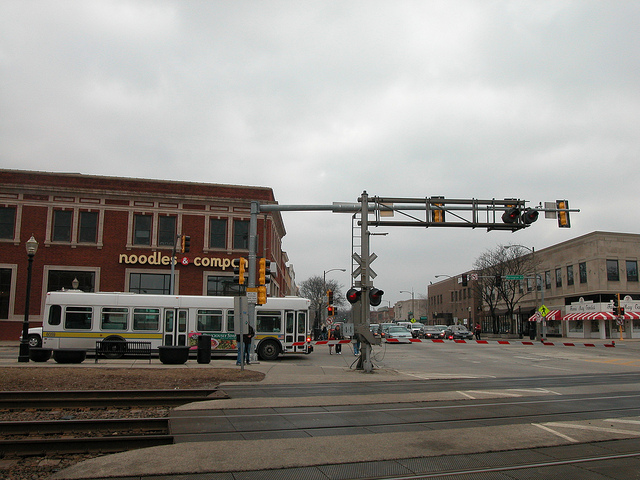<image>In what country was this photo taken? I am not sure in what country this photo was taken. It could be the United States or America. What is the bank on the sign? The bank on the sign is unclear. However, it could be 'Bank of America', 'Chase', or 'US Bank'. What color dress is the woman behind the pole wearing? I don't know the exact color of the dress the woman behind the pole is wearing. It could be blue, white or black. What kind of cars are being sold at the lot? There are no cars being sold in the image. However, cars like sedans or compact cars could potentially be sold. What shape are the stairs? There are no stairs in the image according to some responses, but others suggest they are square or rectangular. What color are the trains? There are no trains in the image. In what country was this photo taken? It is unanswerable in what country the photo was taken. However, it seems to be taken in the United States or USA. What is the bank on the sign? There is no bank on the sign. What color dress is the woman behind the pole wearing? I am not sure what color dress the woman behind the pole is wearing. It could be blue, white, black, or none. What kind of cars are being sold at the lot? I don't know what kind of cars are being sold at the lot. It can be sedans, used cars, or compact cars. What shape are the stairs? I don't know what shape the stairs are. It can be square, rectangular, or none. What color are the trains? There are no trains in the image. 